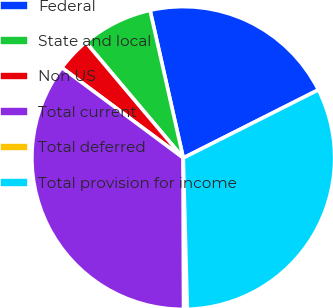<chart> <loc_0><loc_0><loc_500><loc_500><pie_chart><fcel>Federal<fcel>State and local<fcel>Non US<fcel>Total current<fcel>Total deferred<fcel>Total provision for income<nl><fcel>21.09%<fcel>7.62%<fcel>3.68%<fcel>35.22%<fcel>0.38%<fcel>32.01%<nl></chart> 